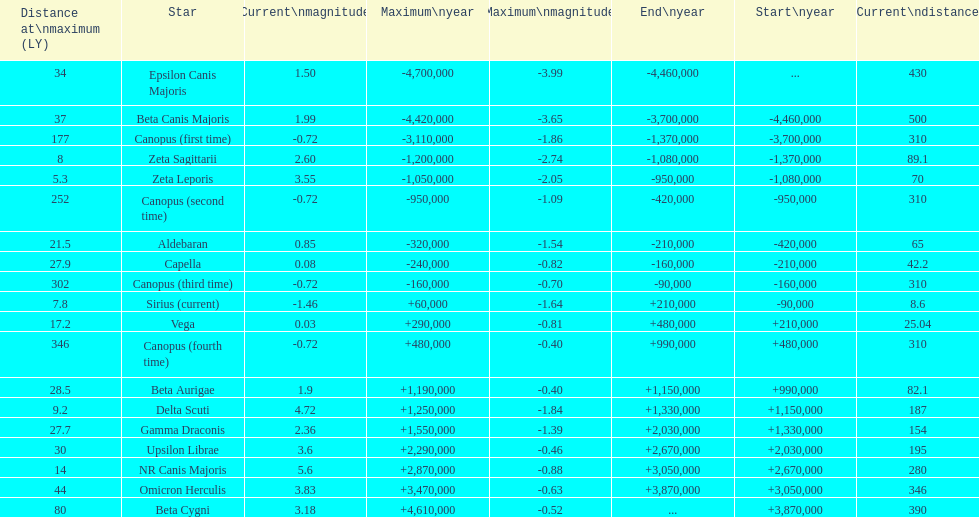How many stars have a magnitude greater than zero? 14. 